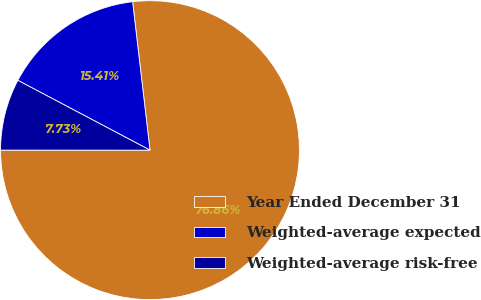<chart> <loc_0><loc_0><loc_500><loc_500><pie_chart><fcel>Year Ended December 31<fcel>Weighted-average expected<fcel>Weighted-average risk-free<nl><fcel>76.87%<fcel>15.41%<fcel>7.73%<nl></chart> 